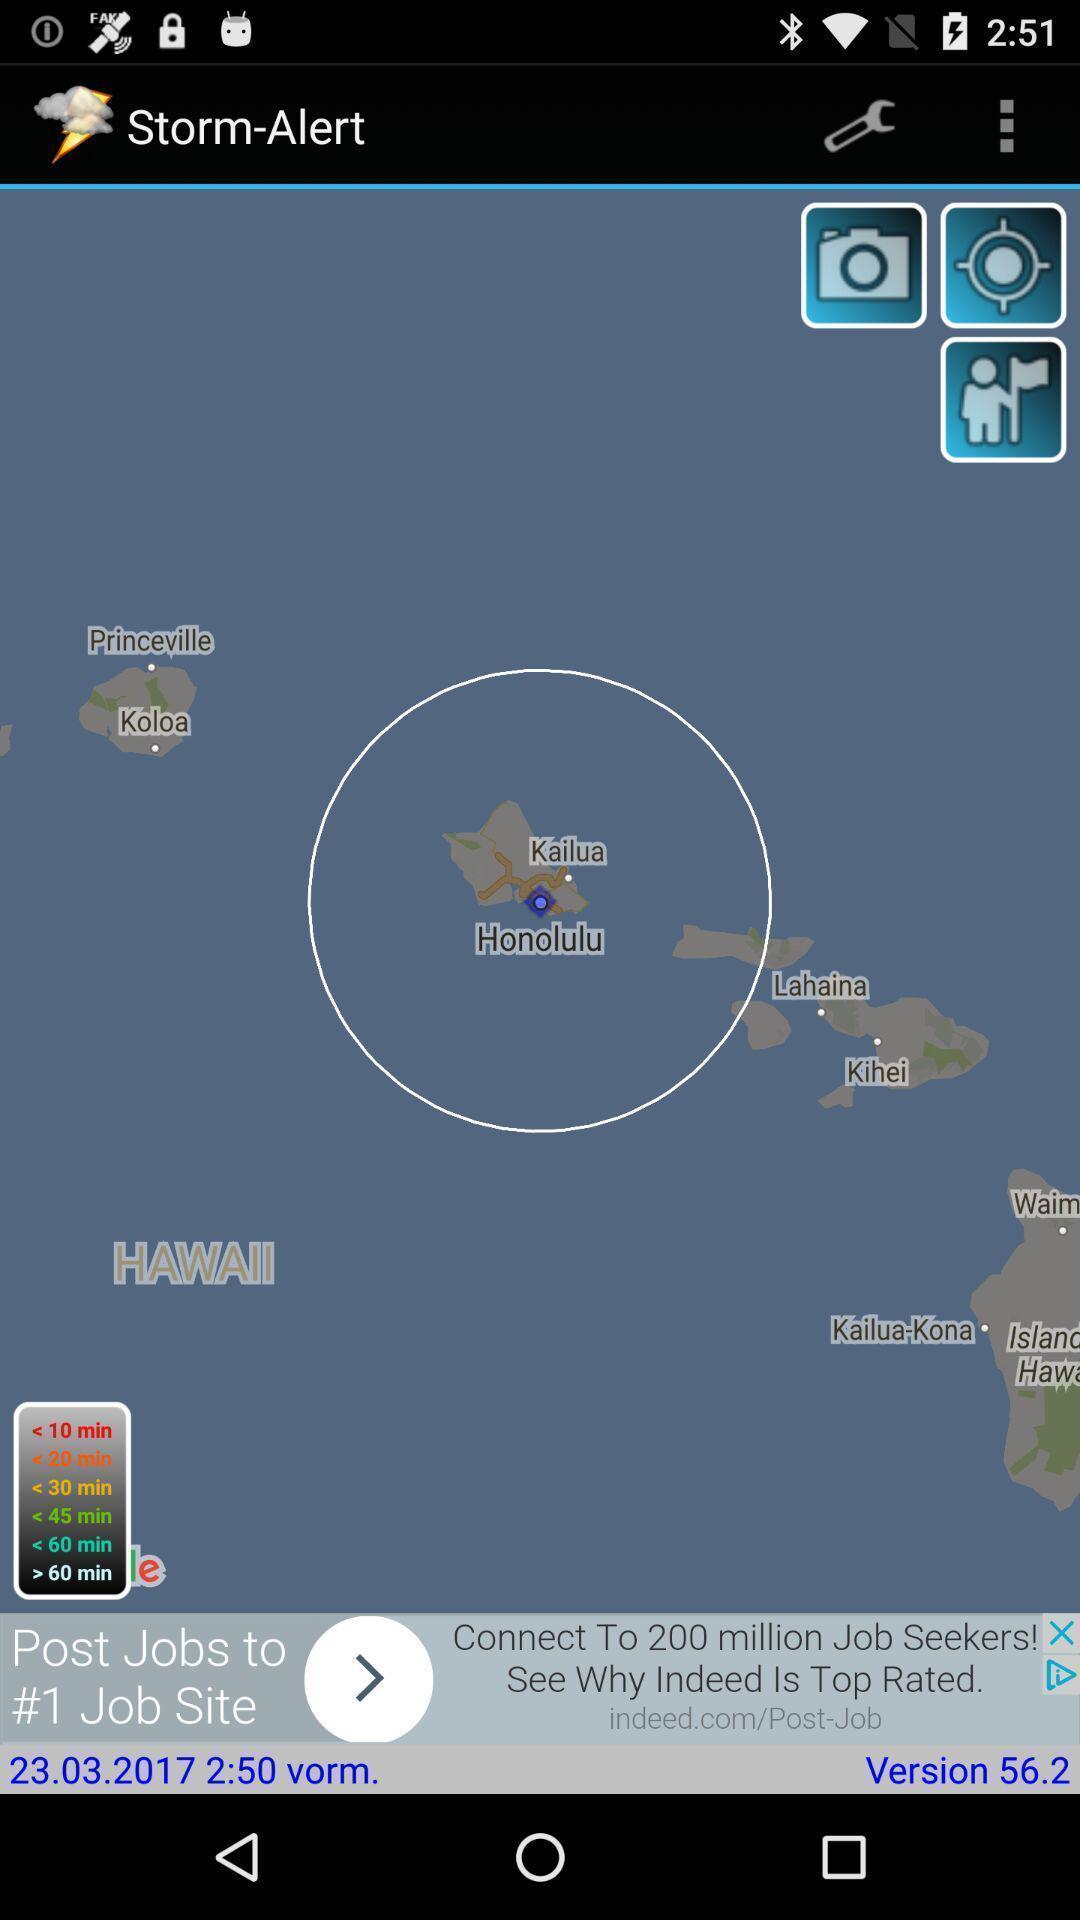Explain what's happening in this screen capture. Storm alert in map app. 